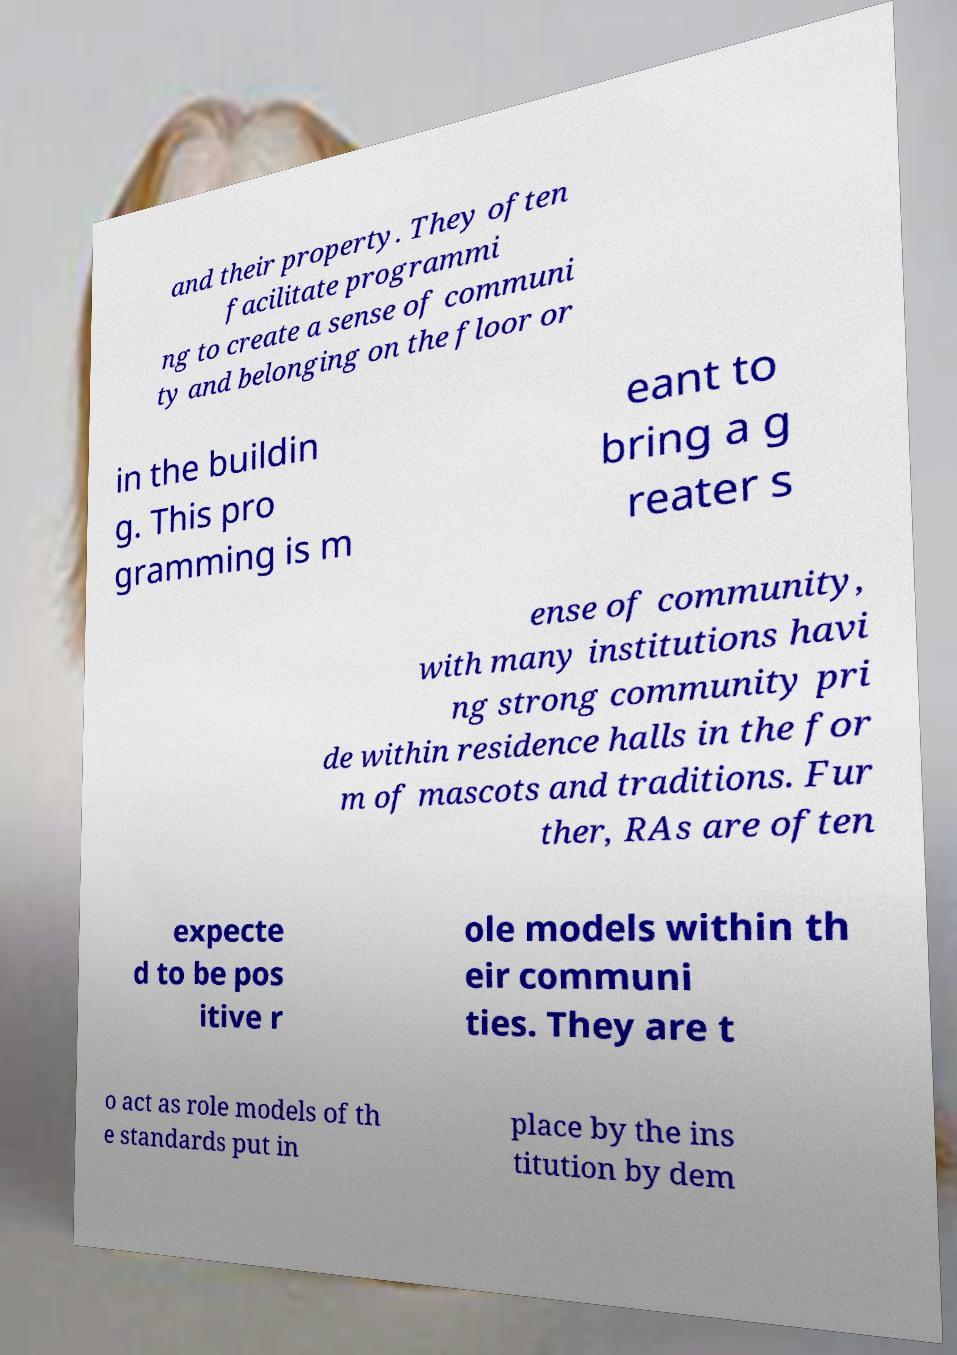Please read and relay the text visible in this image. What does it say? and their property. They often facilitate programmi ng to create a sense of communi ty and belonging on the floor or in the buildin g. This pro gramming is m eant to bring a g reater s ense of community, with many institutions havi ng strong community pri de within residence halls in the for m of mascots and traditions. Fur ther, RAs are often expecte d to be pos itive r ole models within th eir communi ties. They are t o act as role models of th e standards put in place by the ins titution by dem 